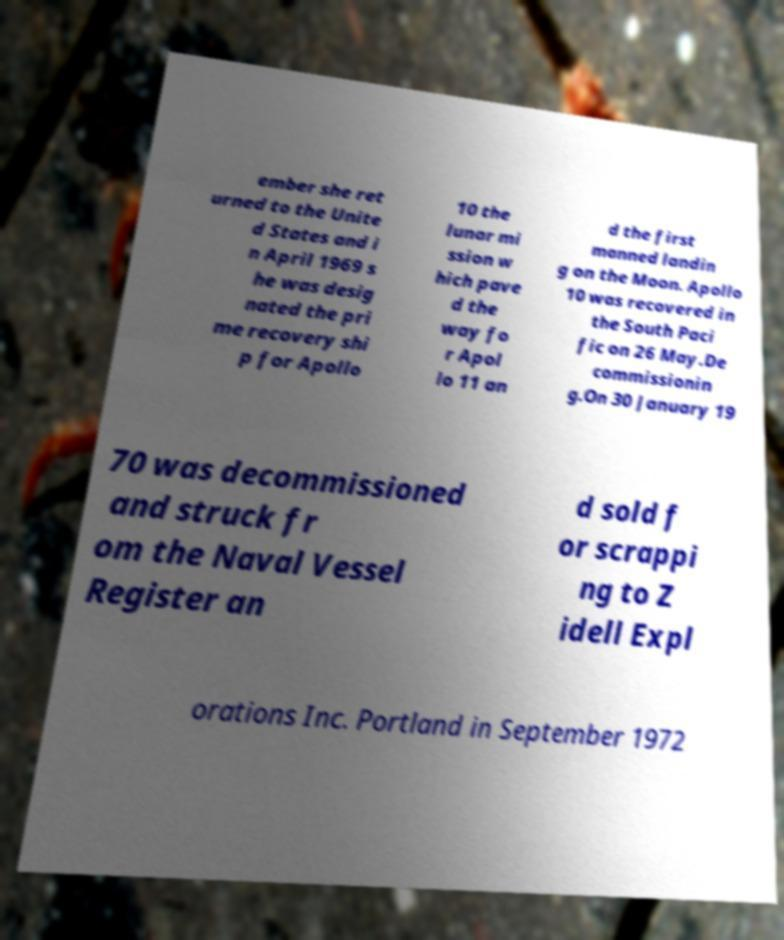Could you extract and type out the text from this image? ember she ret urned to the Unite d States and i n April 1969 s he was desig nated the pri me recovery shi p for Apollo 10 the lunar mi ssion w hich pave d the way fo r Apol lo 11 an d the first manned landin g on the Moon. Apollo 10 was recovered in the South Paci fic on 26 May.De commissionin g.On 30 January 19 70 was decommissioned and struck fr om the Naval Vessel Register an d sold f or scrappi ng to Z idell Expl orations Inc. Portland in September 1972 